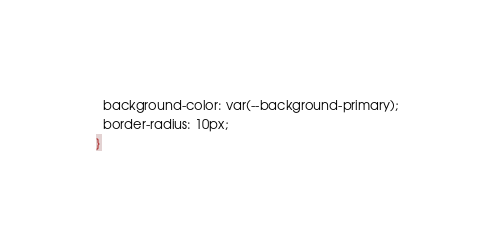<code> <loc_0><loc_0><loc_500><loc_500><_CSS_>  background-color: var(--background-primary);
  border-radius: 10px;
}</code> 